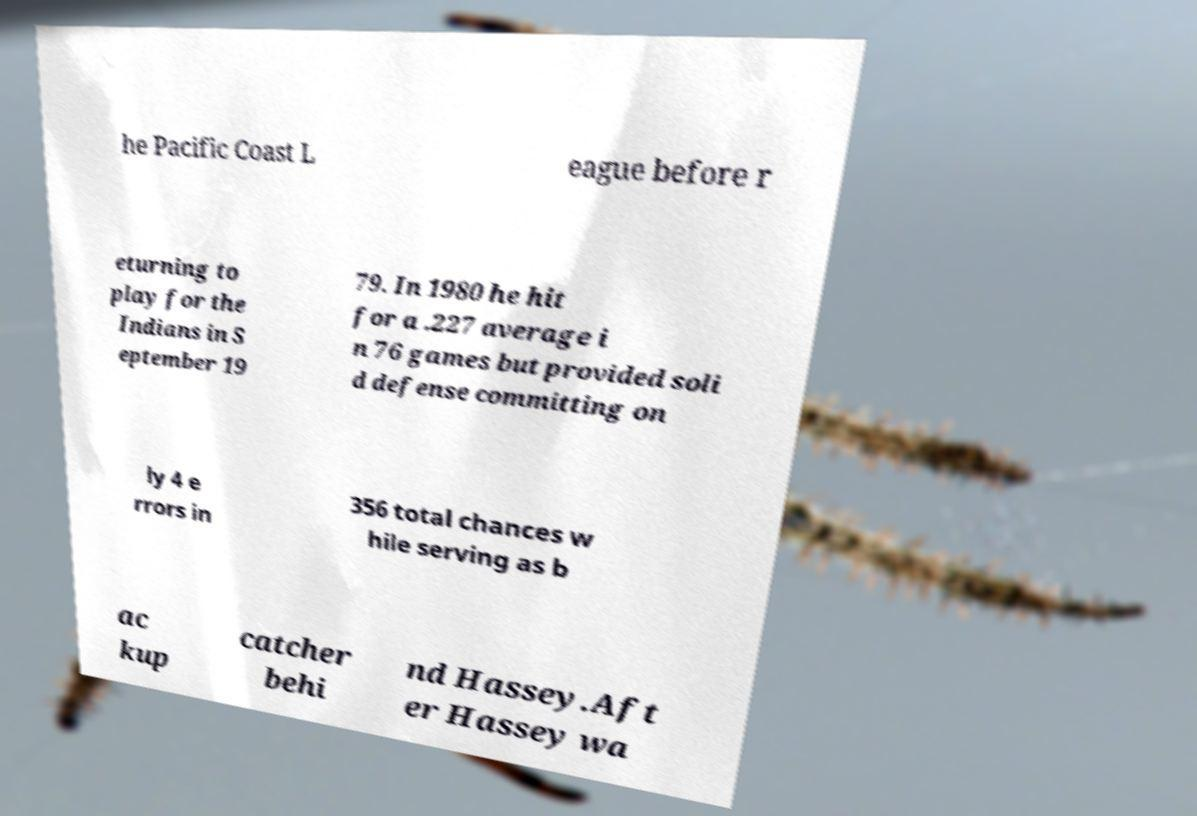Please identify and transcribe the text found in this image. he Pacific Coast L eague before r eturning to play for the Indians in S eptember 19 79. In 1980 he hit for a .227 average i n 76 games but provided soli d defense committing on ly 4 e rrors in 356 total chances w hile serving as b ac kup catcher behi nd Hassey.Aft er Hassey wa 